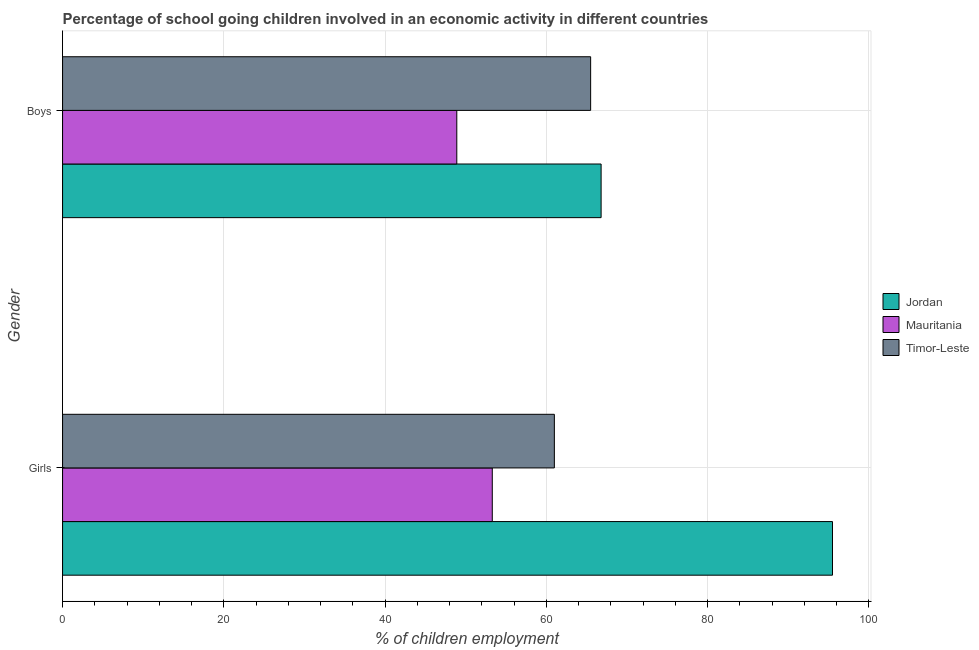How many different coloured bars are there?
Your answer should be compact. 3. How many groups of bars are there?
Make the answer very short. 2. Are the number of bars per tick equal to the number of legend labels?
Provide a succinct answer. Yes. Are the number of bars on each tick of the Y-axis equal?
Give a very brief answer. Yes. How many bars are there on the 2nd tick from the top?
Offer a very short reply. 3. What is the label of the 2nd group of bars from the top?
Make the answer very short. Girls. What is the percentage of school going boys in Timor-Leste?
Make the answer very short. 65.5. Across all countries, what is the maximum percentage of school going girls?
Your answer should be very brief. 95.5. Across all countries, what is the minimum percentage of school going girls?
Provide a succinct answer. 53.3. In which country was the percentage of school going boys maximum?
Provide a succinct answer. Jordan. In which country was the percentage of school going boys minimum?
Give a very brief answer. Mauritania. What is the total percentage of school going boys in the graph?
Give a very brief answer. 181.2. What is the difference between the percentage of school going girls in Timor-Leste and that in Jordan?
Offer a very short reply. -34.5. What is the difference between the percentage of school going boys in Jordan and the percentage of school going girls in Mauritania?
Keep it short and to the point. 13.5. What is the average percentage of school going girls per country?
Keep it short and to the point. 69.93. What is the difference between the percentage of school going girls and percentage of school going boys in Timor-Leste?
Offer a terse response. -4.5. What is the ratio of the percentage of school going girls in Timor-Leste to that in Jordan?
Provide a short and direct response. 0.64. Is the percentage of school going girls in Timor-Leste less than that in Jordan?
Provide a succinct answer. Yes. What does the 2nd bar from the top in Girls represents?
Provide a short and direct response. Mauritania. What does the 3rd bar from the bottom in Girls represents?
Provide a short and direct response. Timor-Leste. Are all the bars in the graph horizontal?
Provide a succinct answer. Yes. Does the graph contain grids?
Give a very brief answer. Yes. Where does the legend appear in the graph?
Your response must be concise. Center right. How many legend labels are there?
Provide a succinct answer. 3. What is the title of the graph?
Your answer should be very brief. Percentage of school going children involved in an economic activity in different countries. What is the label or title of the X-axis?
Give a very brief answer. % of children employment. What is the % of children employment in Jordan in Girls?
Provide a succinct answer. 95.5. What is the % of children employment of Mauritania in Girls?
Offer a very short reply. 53.3. What is the % of children employment in Timor-Leste in Girls?
Your response must be concise. 61. What is the % of children employment in Jordan in Boys?
Your answer should be compact. 66.8. What is the % of children employment in Mauritania in Boys?
Offer a terse response. 48.9. What is the % of children employment of Timor-Leste in Boys?
Provide a succinct answer. 65.5. Across all Gender, what is the maximum % of children employment of Jordan?
Provide a short and direct response. 95.5. Across all Gender, what is the maximum % of children employment of Mauritania?
Give a very brief answer. 53.3. Across all Gender, what is the maximum % of children employment in Timor-Leste?
Give a very brief answer. 65.5. Across all Gender, what is the minimum % of children employment in Jordan?
Your response must be concise. 66.8. Across all Gender, what is the minimum % of children employment in Mauritania?
Ensure brevity in your answer.  48.9. Across all Gender, what is the minimum % of children employment of Timor-Leste?
Your response must be concise. 61. What is the total % of children employment of Jordan in the graph?
Your response must be concise. 162.3. What is the total % of children employment of Mauritania in the graph?
Your response must be concise. 102.2. What is the total % of children employment in Timor-Leste in the graph?
Provide a succinct answer. 126.5. What is the difference between the % of children employment of Jordan in Girls and that in Boys?
Your answer should be very brief. 28.7. What is the difference between the % of children employment of Timor-Leste in Girls and that in Boys?
Your response must be concise. -4.5. What is the difference between the % of children employment of Jordan in Girls and the % of children employment of Mauritania in Boys?
Ensure brevity in your answer.  46.6. What is the difference between the % of children employment of Jordan in Girls and the % of children employment of Timor-Leste in Boys?
Give a very brief answer. 30. What is the average % of children employment of Jordan per Gender?
Ensure brevity in your answer.  81.15. What is the average % of children employment of Mauritania per Gender?
Offer a terse response. 51.1. What is the average % of children employment of Timor-Leste per Gender?
Your answer should be compact. 63.25. What is the difference between the % of children employment in Jordan and % of children employment in Mauritania in Girls?
Your answer should be compact. 42.2. What is the difference between the % of children employment of Jordan and % of children employment of Timor-Leste in Girls?
Keep it short and to the point. 34.5. What is the difference between the % of children employment of Mauritania and % of children employment of Timor-Leste in Girls?
Provide a succinct answer. -7.7. What is the difference between the % of children employment in Jordan and % of children employment in Mauritania in Boys?
Keep it short and to the point. 17.9. What is the difference between the % of children employment of Jordan and % of children employment of Timor-Leste in Boys?
Your response must be concise. 1.3. What is the difference between the % of children employment in Mauritania and % of children employment in Timor-Leste in Boys?
Offer a terse response. -16.6. What is the ratio of the % of children employment of Jordan in Girls to that in Boys?
Make the answer very short. 1.43. What is the ratio of the % of children employment of Mauritania in Girls to that in Boys?
Keep it short and to the point. 1.09. What is the ratio of the % of children employment of Timor-Leste in Girls to that in Boys?
Make the answer very short. 0.93. What is the difference between the highest and the second highest % of children employment of Jordan?
Offer a terse response. 28.7. What is the difference between the highest and the second highest % of children employment in Mauritania?
Provide a short and direct response. 4.4. What is the difference between the highest and the lowest % of children employment in Jordan?
Your answer should be compact. 28.7. What is the difference between the highest and the lowest % of children employment of Mauritania?
Your response must be concise. 4.4. 